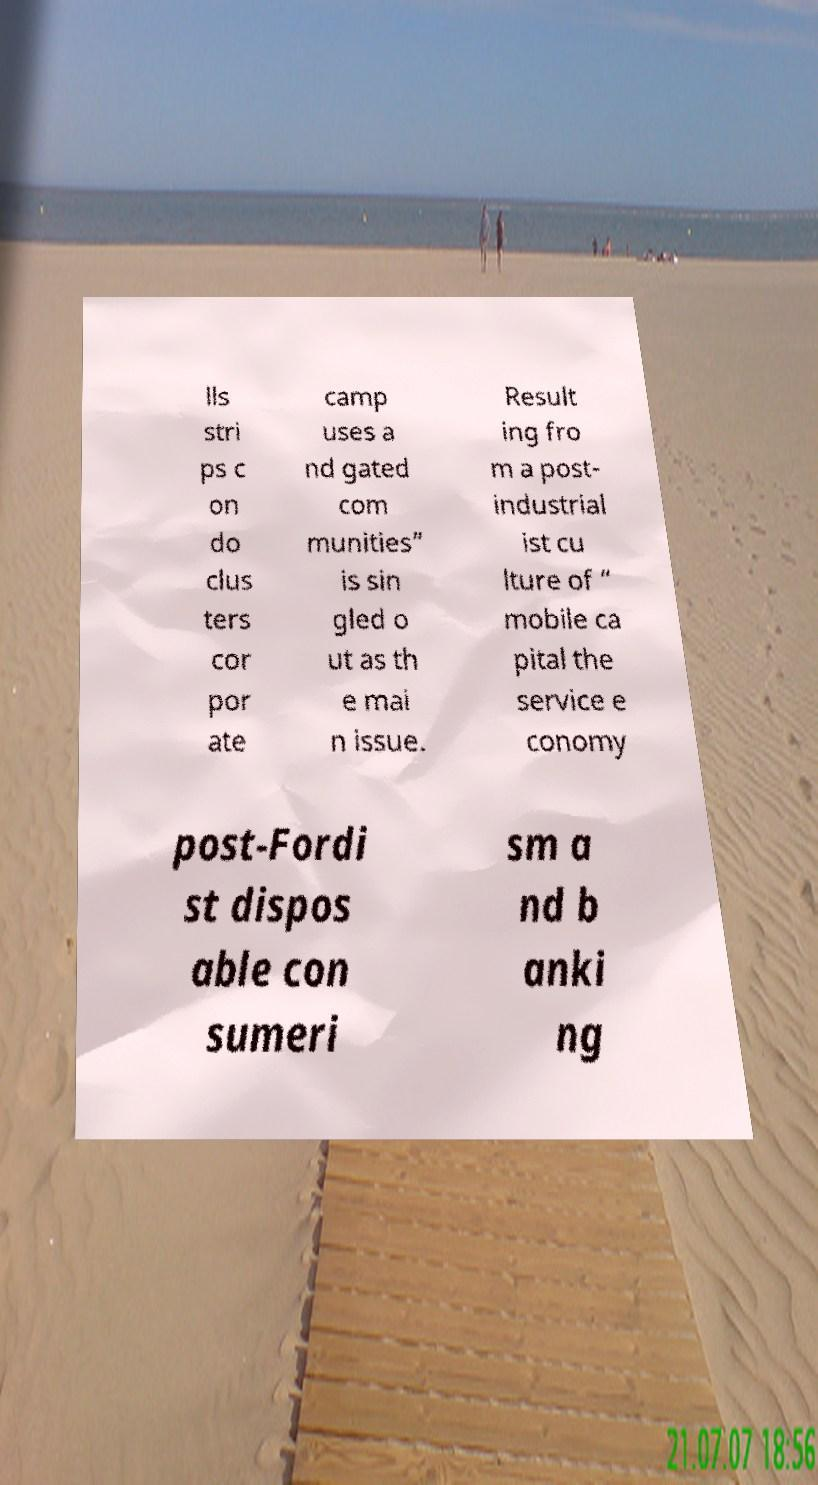Please read and relay the text visible in this image. What does it say? lls stri ps c on do clus ters cor por ate camp uses a nd gated com munities” is sin gled o ut as th e mai n issue. Result ing fro m a post- industrial ist cu lture of “ mobile ca pital the service e conomy post-Fordi st dispos able con sumeri sm a nd b anki ng 